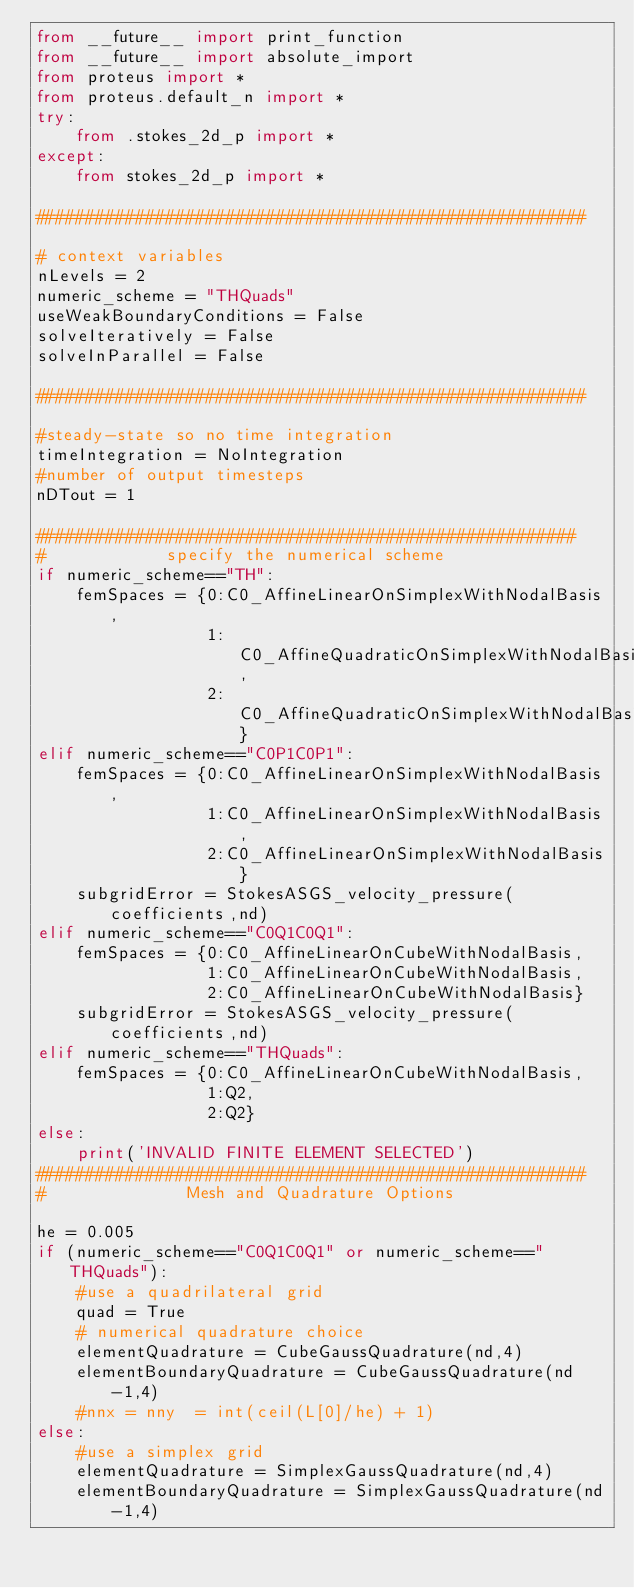<code> <loc_0><loc_0><loc_500><loc_500><_Python_>from __future__ import print_function
from __future__ import absolute_import
from proteus import *
from proteus.default_n import *
try:
    from .stokes_2d_p import *
except:
    from stokes_2d_p import *

#######################################################

# context variables
nLevels = 2
numeric_scheme = "THQuads"
useWeakBoundaryConditions = False
solveIteratively = False
solveInParallel = False

#######################################################

#steady-state so no time integration
timeIntegration = NoIntegration
#number of output timesteps
nDTout = 1

######################################################
#            specify the numerical scheme
if numeric_scheme=="TH":
    femSpaces = {0:C0_AffineLinearOnSimplexWithNodalBasis,
                 1:C0_AffineQuadraticOnSimplexWithNodalBasis,
                 2:C0_AffineQuadraticOnSimplexWithNodalBasis}
elif numeric_scheme=="C0P1C0P1":
    femSpaces = {0:C0_AffineLinearOnSimplexWithNodalBasis,
                 1:C0_AffineLinearOnSimplexWithNodalBasis,
                 2:C0_AffineLinearOnSimplexWithNodalBasis}
    subgridError = StokesASGS_velocity_pressure(coefficients,nd)
elif numeric_scheme=="C0Q1C0Q1":
    femSpaces = {0:C0_AffineLinearOnCubeWithNodalBasis,
                 1:C0_AffineLinearOnCubeWithNodalBasis,
                 2:C0_AffineLinearOnCubeWithNodalBasis}
    subgridError = StokesASGS_velocity_pressure(coefficients,nd)
elif numeric_scheme=="THQuads":
    femSpaces = {0:C0_AffineLinearOnCubeWithNodalBasis,
                 1:Q2,
                 2:Q2}
else:
    print('INVALID FINITE ELEMENT SELECTED')
#######################################################
#              Mesh and Quadrature Options

he = 0.005
if (numeric_scheme=="C0Q1C0Q1" or numeric_scheme=="THQuads"):
    #use a quadrilateral grid
    quad = True
    # numerical quadrature choice
    elementQuadrature = CubeGaussQuadrature(nd,4)
    elementBoundaryQuadrature = CubeGaussQuadrature(nd-1,4)
    #nnx = nny  = int(ceil(L[0]/he) + 1)
else:
    #use a simplex grid
    elementQuadrature = SimplexGaussQuadrature(nd,4)
    elementBoundaryQuadrature = SimplexGaussQuadrature(nd-1,4)</code> 